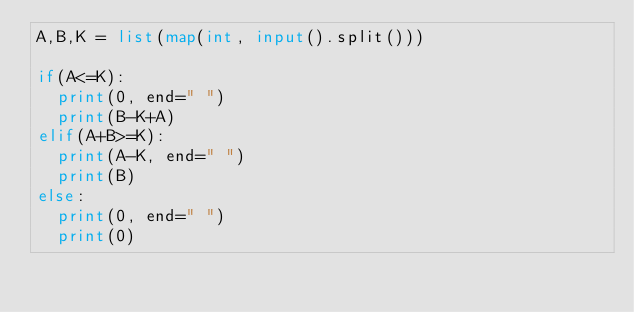<code> <loc_0><loc_0><loc_500><loc_500><_Python_>A,B,K = list(map(int, input().split()))

if(A<=K):
  print(0, end=" ")
  print(B-K+A)
elif(A+B>=K):
  print(A-K, end=" ")
  print(B)
else:
  print(0, end=" ")
  print(0)</code> 